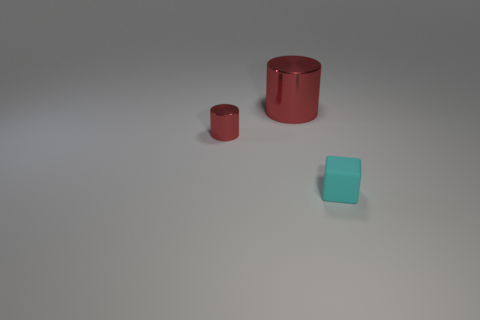Add 3 small cyan things. How many objects exist? 6 Subtract all cylinders. How many objects are left? 1 Subtract all matte cubes. Subtract all small matte cubes. How many objects are left? 1 Add 1 large metallic objects. How many large metallic objects are left? 2 Add 2 tiny balls. How many tiny balls exist? 2 Subtract 0 yellow spheres. How many objects are left? 3 